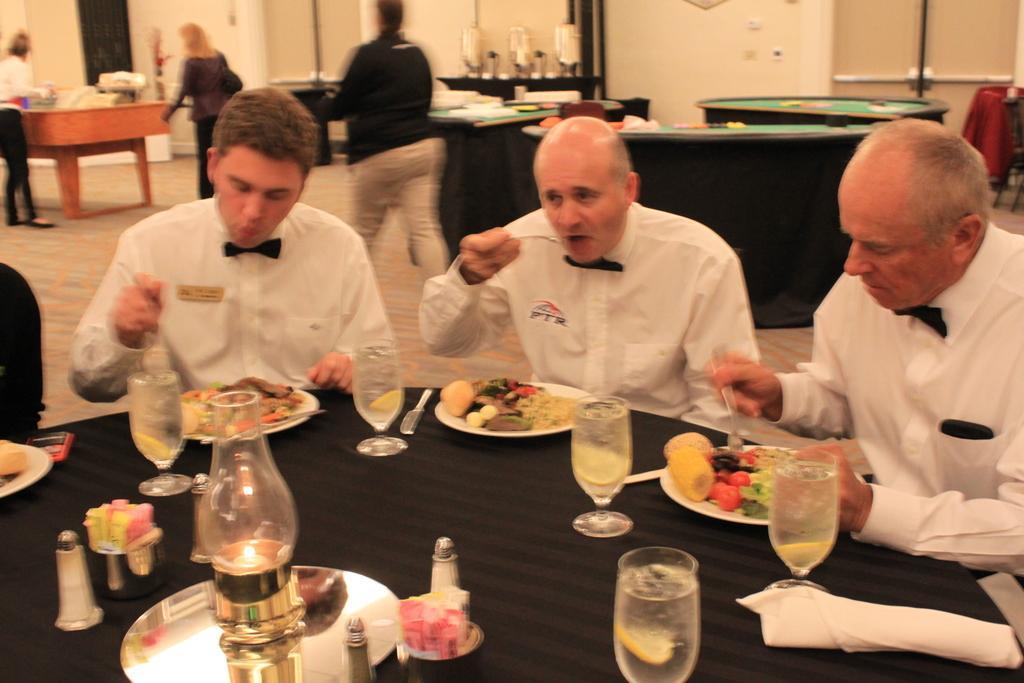Could you give a brief overview of what you see in this image? In the image there are three men sat around the dining table,there are food wine glasses on it and this picture seems to be inside a restaurant,In the background there are two woman and a man walking. 